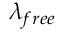Convert formula to latex. <formula><loc_0><loc_0><loc_500><loc_500>\lambda _ { f r e e }</formula> 